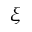<formula> <loc_0><loc_0><loc_500><loc_500>\xi</formula> 